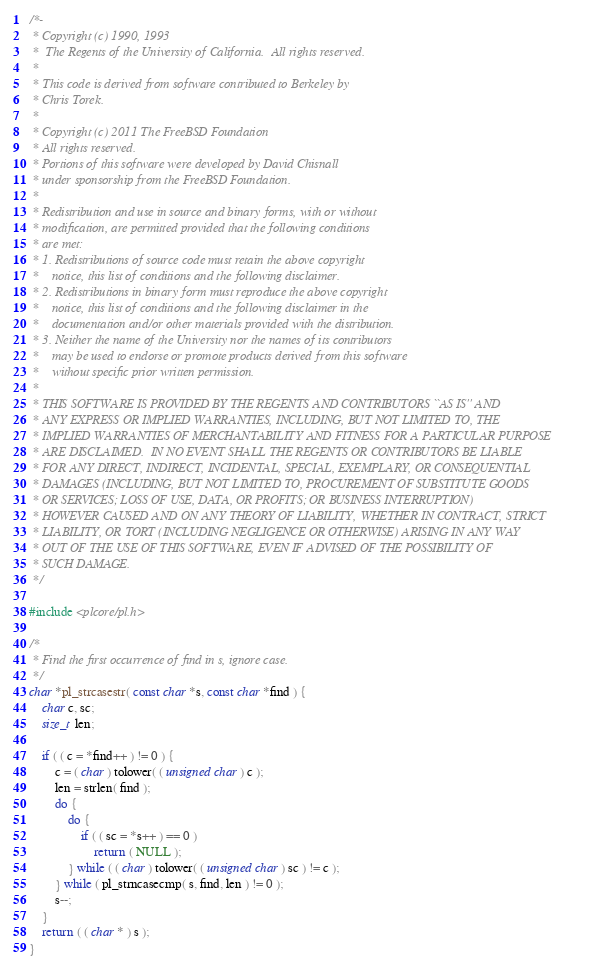Convert code to text. <code><loc_0><loc_0><loc_500><loc_500><_C_>/*-
 * Copyright (c) 1990, 1993
 *	The Regents of the University of California.  All rights reserved.
 *
 * This code is derived from software contributed to Berkeley by
 * Chris Torek.
 *
 * Copyright (c) 2011 The FreeBSD Foundation
 * All rights reserved.
 * Portions of this software were developed by David Chisnall
 * under sponsorship from the FreeBSD Foundation.
 *
 * Redistribution and use in source and binary forms, with or without
 * modification, are permitted provided that the following conditions
 * are met:
 * 1. Redistributions of source code must retain the above copyright
 *    notice, this list of conditions and the following disclaimer.
 * 2. Redistributions in binary form must reproduce the above copyright
 *    notice, this list of conditions and the following disclaimer in the
 *    documentation and/or other materials provided with the distribution.
 * 3. Neither the name of the University nor the names of its contributors
 *    may be used to endorse or promote products derived from this software
 *    without specific prior written permission.
 *
 * THIS SOFTWARE IS PROVIDED BY THE REGENTS AND CONTRIBUTORS ``AS IS'' AND
 * ANY EXPRESS OR IMPLIED WARRANTIES, INCLUDING, BUT NOT LIMITED TO, THE
 * IMPLIED WARRANTIES OF MERCHANTABILITY AND FITNESS FOR A PARTICULAR PURPOSE
 * ARE DISCLAIMED.  IN NO EVENT SHALL THE REGENTS OR CONTRIBUTORS BE LIABLE
 * FOR ANY DIRECT, INDIRECT, INCIDENTAL, SPECIAL, EXEMPLARY, OR CONSEQUENTIAL
 * DAMAGES (INCLUDING, BUT NOT LIMITED TO, PROCUREMENT OF SUBSTITUTE GOODS
 * OR SERVICES; LOSS OF USE, DATA, OR PROFITS; OR BUSINESS INTERRUPTION)
 * HOWEVER CAUSED AND ON ANY THEORY OF LIABILITY, WHETHER IN CONTRACT, STRICT
 * LIABILITY, OR TORT (INCLUDING NEGLIGENCE OR OTHERWISE) ARISING IN ANY WAY
 * OUT OF THE USE OF THIS SOFTWARE, EVEN IF ADVISED OF THE POSSIBILITY OF
 * SUCH DAMAGE.
 */

#include <plcore/pl.h>

/*
 * Find the first occurrence of find in s, ignore case.
 */
char *pl_strcasestr( const char *s, const char *find ) {
	char c, sc;
	size_t len;

	if ( ( c = *find++ ) != 0 ) {
		c = ( char ) tolower( ( unsigned char ) c );
		len = strlen( find );
		do {
			do {
				if ( ( sc = *s++ ) == 0 )
					return ( NULL );
			} while ( ( char ) tolower( ( unsigned char ) sc ) != c );
		} while ( pl_strncasecmp( s, find, len ) != 0 );
		s--;
	}
	return ( ( char * ) s );
}
</code> 